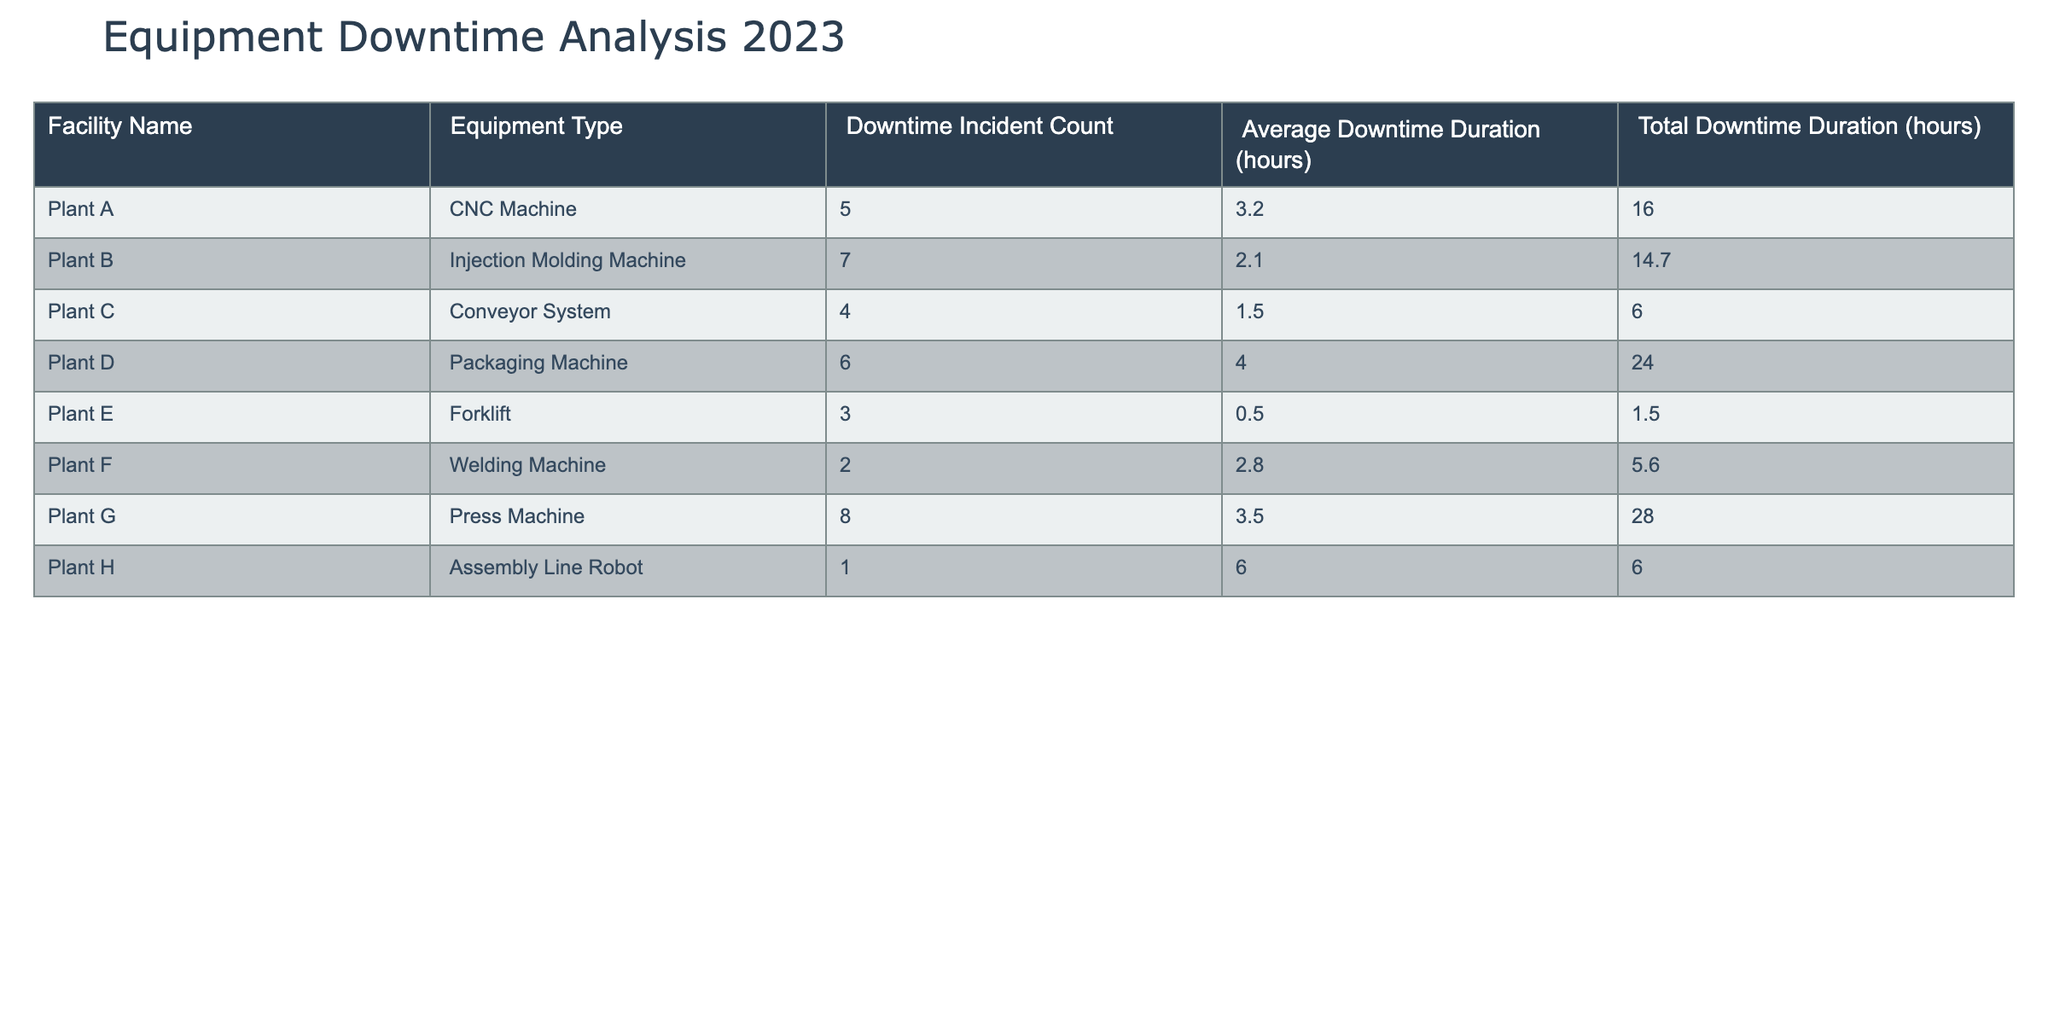What facility had the highest total downtime duration? By examining the "Total Downtime Duration (hours)" column, we can see that Plant G has the highest value at 28.0 hours.
Answer: Plant G Which facility experienced the least average downtime duration? Looking at the "Average Downtime Duration (hours)" column, Plant E has the lowest average at 0.5 hours.
Answer: Plant E How many total downtime incidents occurred across all facilities? We sum the "Downtime Incident Count" for all facilities: 5 + 7 + 4 + 6 + 3 + 2 + 8 + 1 = 36 incidents in total.
Answer: 36 What is the average downtime duration of all facilities combined? The total downtime duration is 16.0 + 14.7 + 6.0 + 24.0 + 1.5 + 5.6 + 28.0 + 6.0 = 92.8 hours. Dividing this by the number of facilities (8) gives us an average of 92.8/8 = 11.6 hours.
Answer: 11.6 Is there a facility with more than 6 downtime incidents? Yes, Plant B and Plant G have 7 and 8 downtime incidents, respectively, which are both greater than 6.
Answer: Yes Which equipment type had the highest average downtime duration? By comparing the "Average Downtime Duration (hours)", we find that the Packaging Machine at Plant D has the highest average at 4.0 hours.
Answer: Packaging Machine What is the total downtime duration for all facilities with more than 6 downtime incidents? From the table, Plant B and Plant G have more than 6 incidents. Their total downtimes are 14.7 hours and 28.0 hours, respectively, summing up to 14.7 + 28.0 = 42.7 hours.
Answer: 42.7 Was there a facility that had only one downtime incident? Yes, Plant H experienced only one downtime incident.
Answer: Yes What is the total downtime duration of Plant A and Plant B combined? Plant A has a total downtime of 16.0 hours, and Plant B has 14.7 hours. Adding these gives us 16.0 + 14.7 = 30.7 hours.
Answer: 30.7 